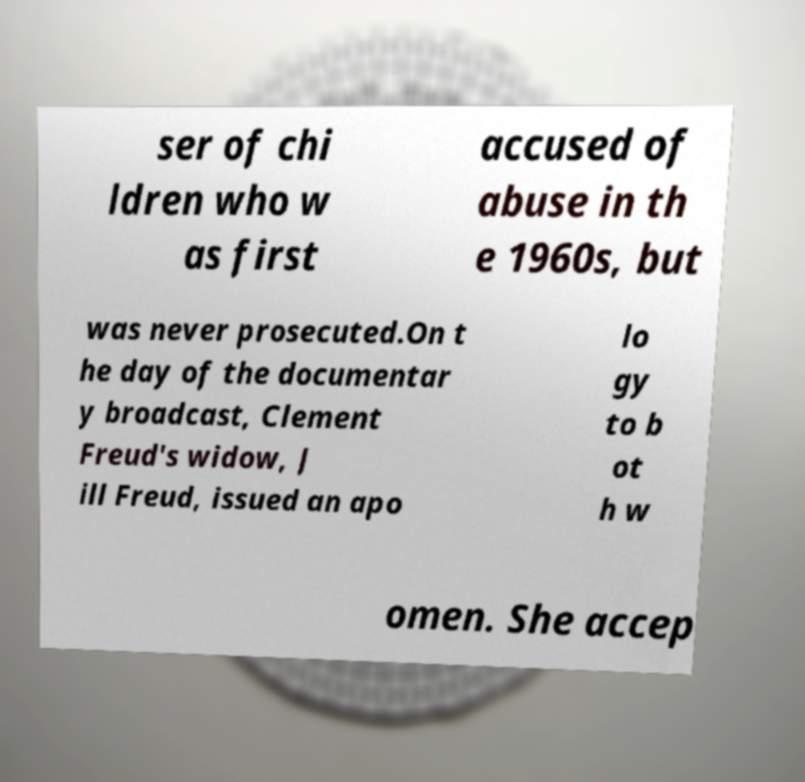Could you extract and type out the text from this image? ser of chi ldren who w as first accused of abuse in th e 1960s, but was never prosecuted.On t he day of the documentar y broadcast, Clement Freud's widow, J ill Freud, issued an apo lo gy to b ot h w omen. She accep 